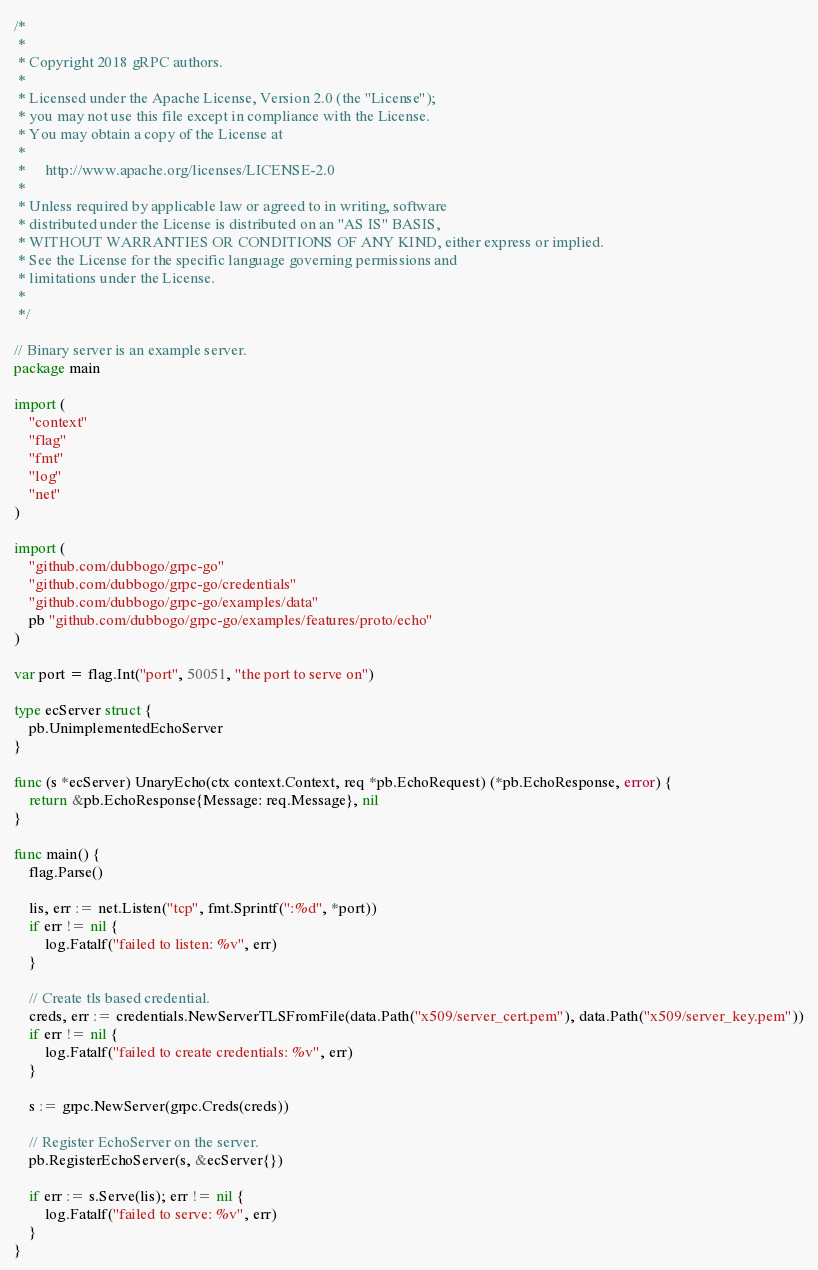Convert code to text. <code><loc_0><loc_0><loc_500><loc_500><_Go_>/*
 *
 * Copyright 2018 gRPC authors.
 *
 * Licensed under the Apache License, Version 2.0 (the "License");
 * you may not use this file except in compliance with the License.
 * You may obtain a copy of the License at
 *
 *     http://www.apache.org/licenses/LICENSE-2.0
 *
 * Unless required by applicable law or agreed to in writing, software
 * distributed under the License is distributed on an "AS IS" BASIS,
 * WITHOUT WARRANTIES OR CONDITIONS OF ANY KIND, either express or implied.
 * See the License for the specific language governing permissions and
 * limitations under the License.
 *
 */

// Binary server is an example server.
package main

import (
	"context"
	"flag"
	"fmt"
	"log"
	"net"
)

import (
	"github.com/dubbogo/grpc-go"
	"github.com/dubbogo/grpc-go/credentials"
	"github.com/dubbogo/grpc-go/examples/data"
	pb "github.com/dubbogo/grpc-go/examples/features/proto/echo"
)

var port = flag.Int("port", 50051, "the port to serve on")

type ecServer struct {
	pb.UnimplementedEchoServer
}

func (s *ecServer) UnaryEcho(ctx context.Context, req *pb.EchoRequest) (*pb.EchoResponse, error) {
	return &pb.EchoResponse{Message: req.Message}, nil
}

func main() {
	flag.Parse()

	lis, err := net.Listen("tcp", fmt.Sprintf(":%d", *port))
	if err != nil {
		log.Fatalf("failed to listen: %v", err)
	}

	// Create tls based credential.
	creds, err := credentials.NewServerTLSFromFile(data.Path("x509/server_cert.pem"), data.Path("x509/server_key.pem"))
	if err != nil {
		log.Fatalf("failed to create credentials: %v", err)
	}

	s := grpc.NewServer(grpc.Creds(creds))

	// Register EchoServer on the server.
	pb.RegisterEchoServer(s, &ecServer{})

	if err := s.Serve(lis); err != nil {
		log.Fatalf("failed to serve: %v", err)
	}
}
</code> 